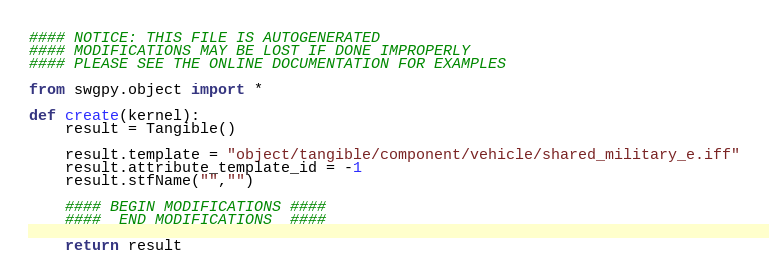Convert code to text. <code><loc_0><loc_0><loc_500><loc_500><_Python_>#### NOTICE: THIS FILE IS AUTOGENERATED
#### MODIFICATIONS MAY BE LOST IF DONE IMPROPERLY
#### PLEASE SEE THE ONLINE DOCUMENTATION FOR EXAMPLES

from swgpy.object import *	

def create(kernel):
	result = Tangible()

	result.template = "object/tangible/component/vehicle/shared_military_e.iff"
	result.attribute_template_id = -1
	result.stfName("","")		
	
	#### BEGIN MODIFICATIONS ####
	####  END MODIFICATIONS  ####
	
	return result</code> 